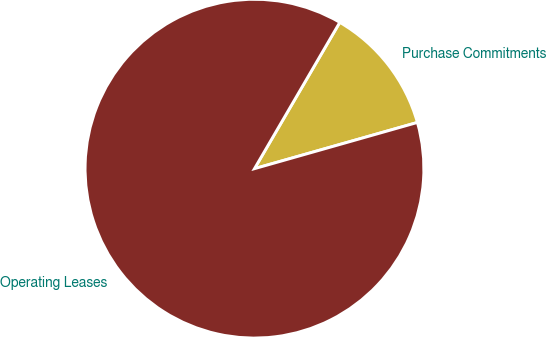Convert chart to OTSL. <chart><loc_0><loc_0><loc_500><loc_500><pie_chart><fcel>Purchase Commitments<fcel>Operating Leases<nl><fcel>12.2%<fcel>87.8%<nl></chart> 